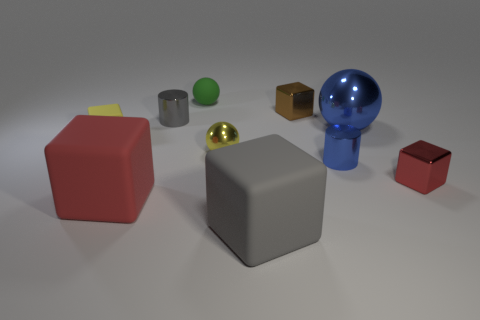Subtract 2 blocks. How many blocks are left? 3 Subtract all shiny blocks. How many blocks are left? 3 Subtract all brown cubes. How many cubes are left? 4 Subtract all gray blocks. Subtract all brown balls. How many blocks are left? 4 Subtract all balls. How many objects are left? 7 Add 7 tiny yellow objects. How many tiny yellow objects exist? 9 Subtract 0 cyan cylinders. How many objects are left? 10 Subtract all yellow metal things. Subtract all tiny red things. How many objects are left? 8 Add 6 small red metal blocks. How many small red metal blocks are left? 7 